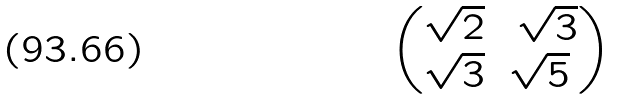<formula> <loc_0><loc_0><loc_500><loc_500>\begin{pmatrix} \sqrt { 2 } & \ \sqrt { 3 } \\ \sqrt { 3 } & \sqrt { 5 } \end{pmatrix}</formula> 